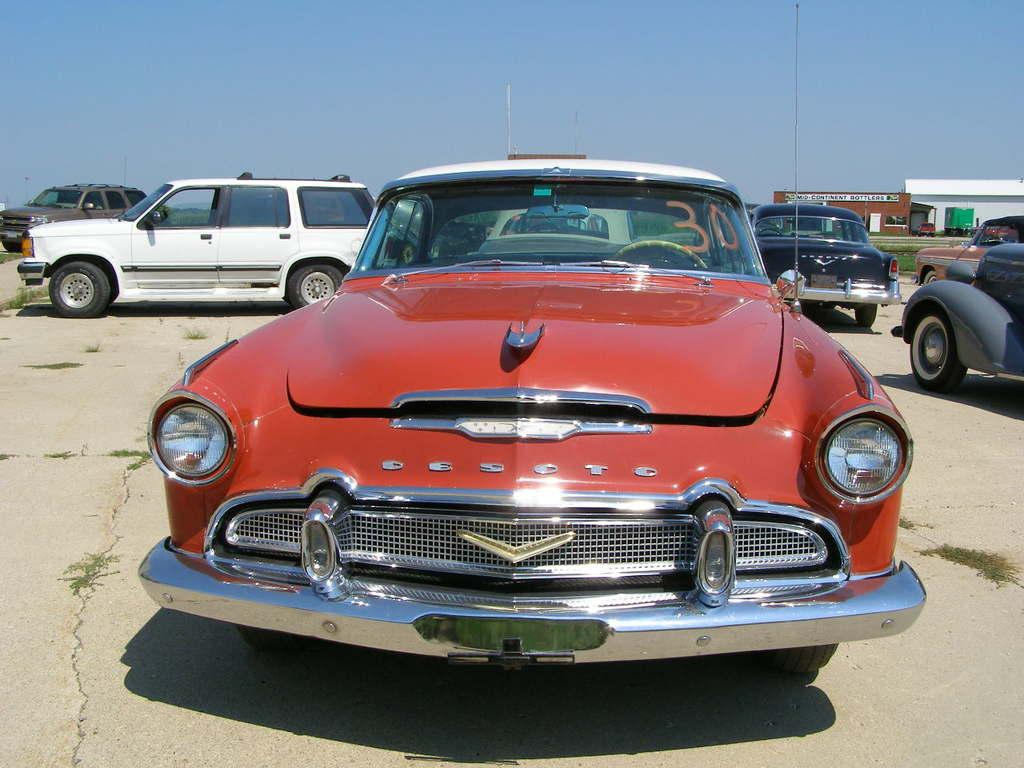What is the main subject in the center of the image? There are cars in the center of the image. What structure can be seen on the right side of the image? There is a building on the right side of the image. What is visible in the background of the image? The sky is visible in the background of the image. How does the visitor interact with the memory in the image? There is no visitor or memory present in the image. 